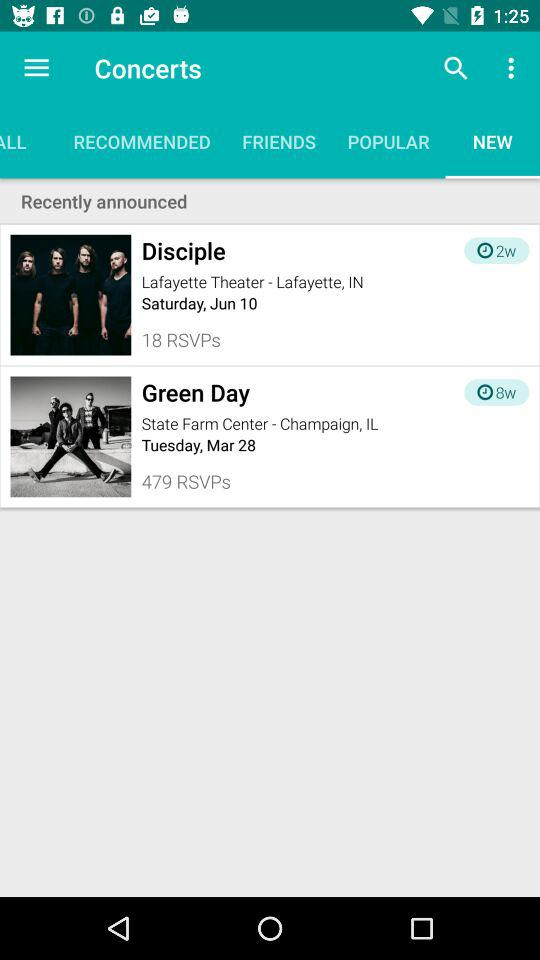For which date is the "Disciple" concert scheduled? The "Disciple" concert is scheduled for Saturday, June 10. 